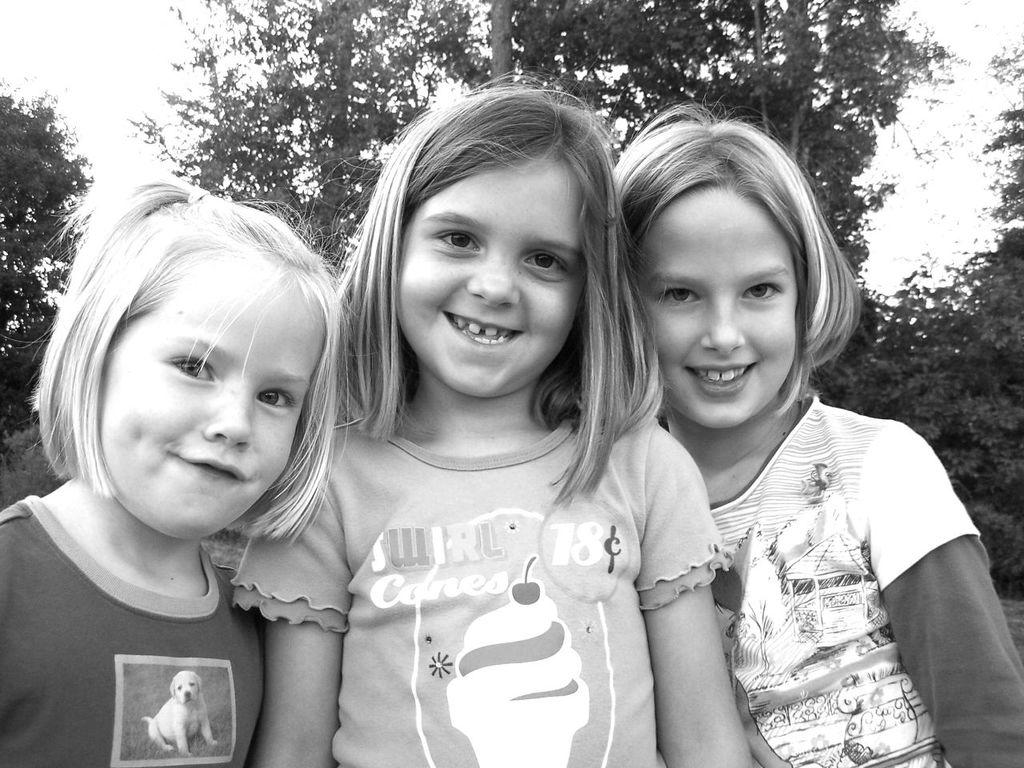What is the color scheme of the image? The image is black and white. Can you describe the people in the image? There are a few people in the image. What type of vegetation is present in the image? There are trees and plants in the image. What part of the natural environment is visible in the image? The sky is visible in the image. How many rabbits can be seen playing with dogs in the image? There are no rabbits or dogs present in the image. What country is depicted in the image? The image does not depict a specific country; it is a black and white image with people, trees, plants, and the sky. 